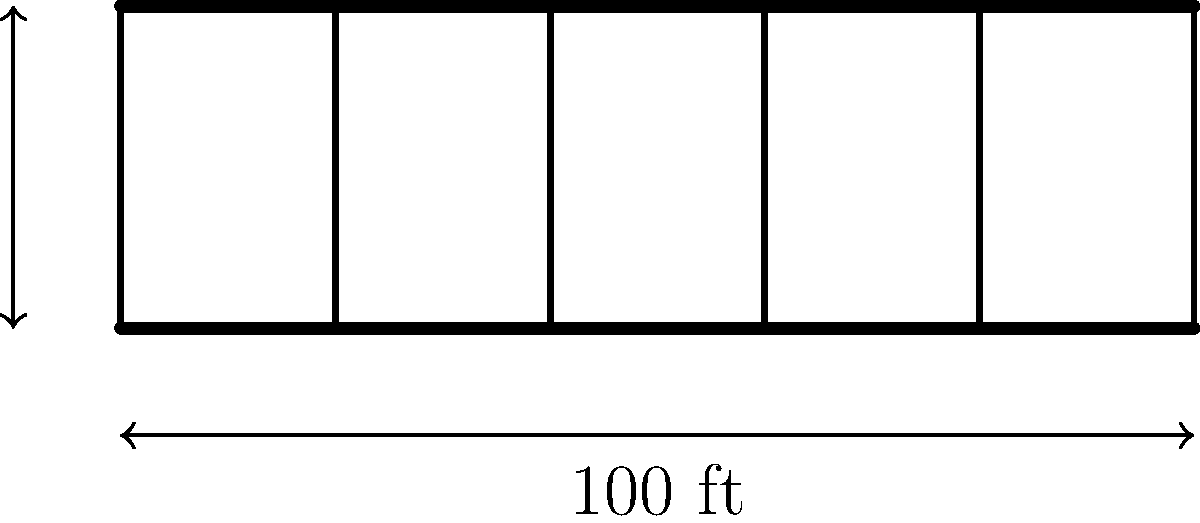The Perrine Bridge, a historic structure in Twin Falls, Idaho, spans 100 feet and stands 30 feet tall. If the bridge is designed to support a maximum load of 50 tons at its center, what is the maximum bending moment experienced by the bridge? Assume the bridge can be modeled as a simply supported beam. To find the maximum bending moment for the Perrine Bridge, we'll follow these steps:

1. Identify the problem as a simply supported beam with a point load at the center.

2. Calculate the reactions at the supports:
   Since the load is at the center, each support bears half the total load.
   $R_A = R_B = \frac{50 \text{ tons}}{2} = 25 \text{ tons}$

3. Use the bending moment equation for a simply supported beam with a center point load:
   $M_{\text{max}} = \frac{PL}{4}$
   Where:
   $P$ = point load (50 tons)
   $L$ = span length (100 feet)

4. Substitute the values:
   $M_{\text{max}} = \frac{50 \text{ tons} \times 100 \text{ ft}}{4}$

5. Calculate the result:
   $M_{\text{max}} = 1250 \text{ ton-ft}$

This maximum bending moment occurs at the center of the bridge, directly under the applied load.
Answer: 1250 ton-ft 